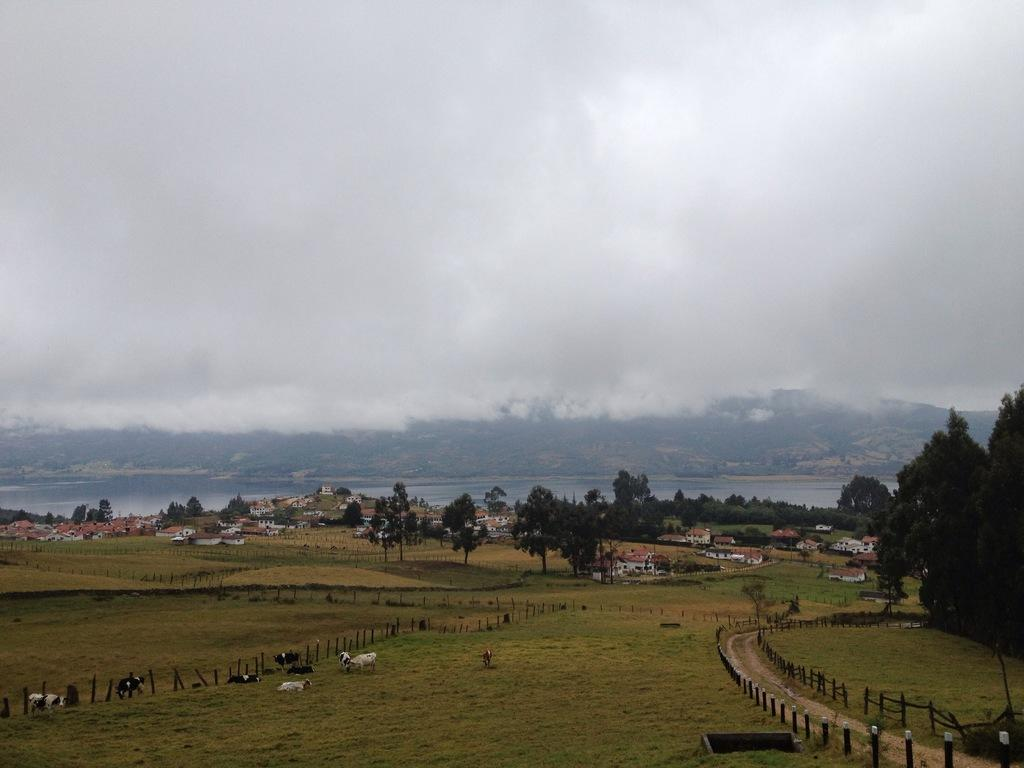What type of animals can be seen in the image? There are animals on the grass in the image. What is the purpose of the fence visible in the image? The fence is likely used to separate or enclose certain areas in the image. What type of pathway is present in the image? There is a road in the image. What type of structures can be seen in the image? There are houses in the image. What type of vegetation is present in the image? Trees are present in the image. What type of natural feature can be seen in the image? There is water visible in the image. What type of terrain can be seen in the image? There are hills in the image. What is the condition of the sky in the background of the image? The sky is cloudy in the background of the image. What type of arch can be seen in the image? There is no arch present in the image. How many snails can be seen on the grass in the image? There are no snails visible in the image. 